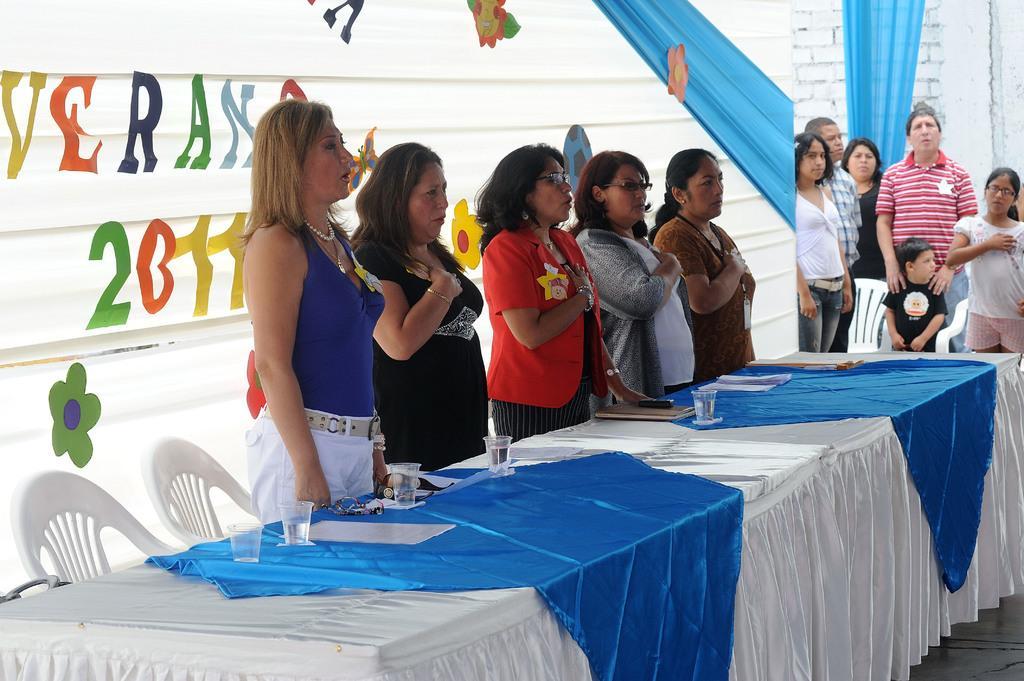Describe this image in one or two sentences. This image consists of a banner back side and table in the middle, table has a cloth on it and it has glasses, paper, book, mobile phone on it. There are people standing near the table and on the right side corner there are also people standing. There are chairs in this image. 